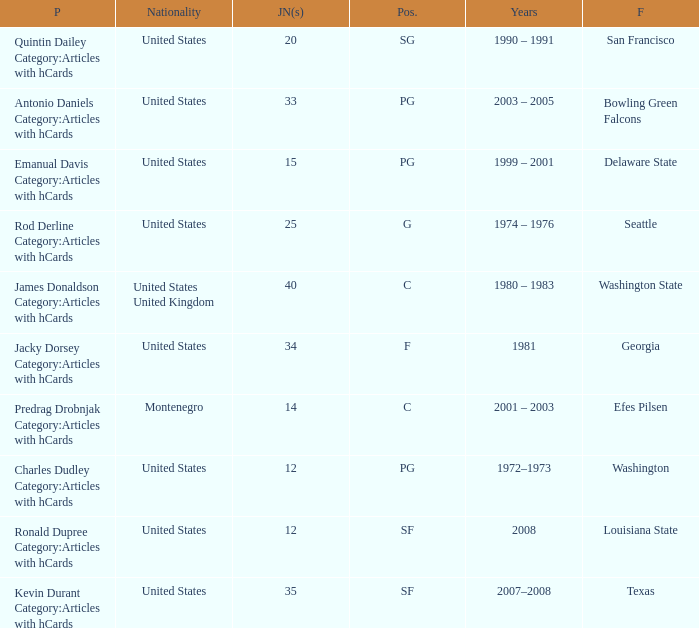What is the lowest jersey number of a player from louisiana state? 12.0. 